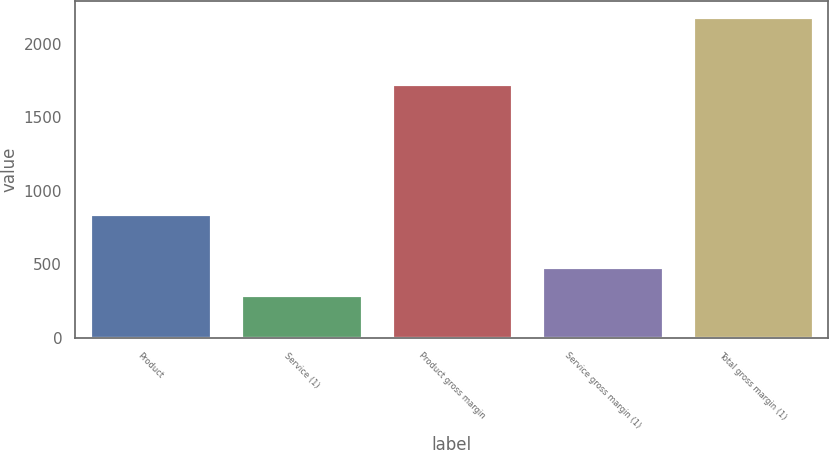Convert chart. <chart><loc_0><loc_0><loc_500><loc_500><bar_chart><fcel>Product<fcel>Service (1)<fcel>Product gross margin<fcel>Service gross margin (1)<fcel>Total gross margin (1)<nl><fcel>841.7<fcel>291<fcel>1726.3<fcel>480.22<fcel>2183.2<nl></chart> 